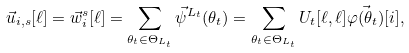<formula> <loc_0><loc_0><loc_500><loc_500>\vec { u } _ { i , s } [ \ell ] = \vec { w } _ { i } ^ { s } [ \ell ] = \sum _ { \theta _ { t } \in \Theta _ { L _ { t } } } \vec { \psi } ^ { L _ { t } } ( \theta _ { t } ) = \sum _ { \theta _ { t } \in \Theta _ { L _ { t } } } U _ { t } [ \ell , \ell ] \vec { \varphi ( \theta _ { t } ) } [ i ] ,</formula> 